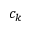<formula> <loc_0><loc_0><loc_500><loc_500>c _ { k }</formula> 